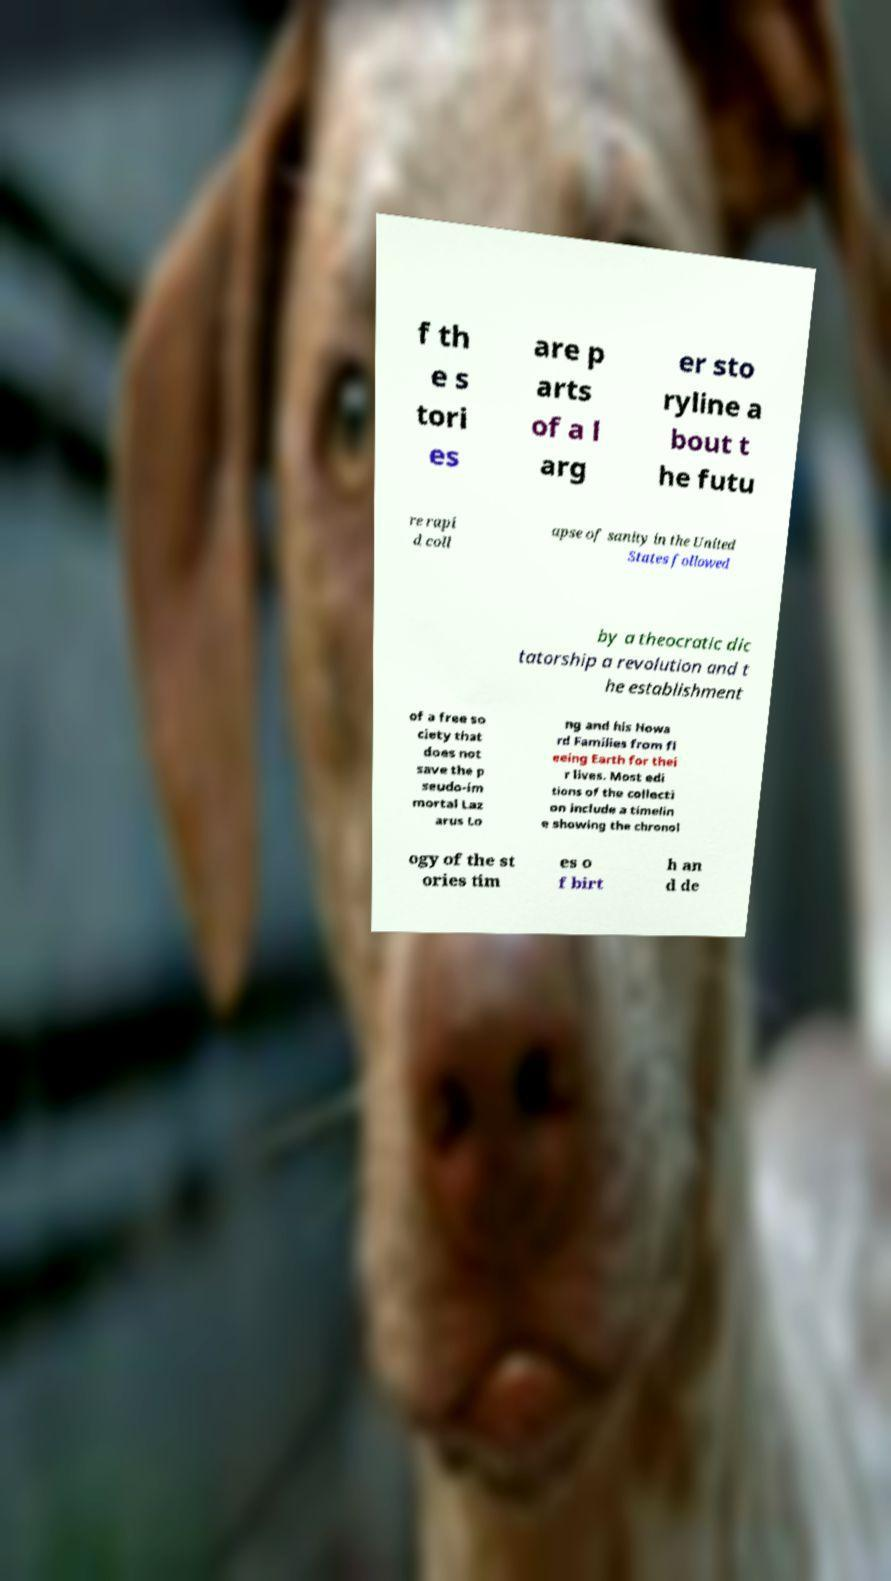What messages or text are displayed in this image? I need them in a readable, typed format. f th e s tori es are p arts of a l arg er sto ryline a bout t he futu re rapi d coll apse of sanity in the United States followed by a theocratic dic tatorship a revolution and t he establishment of a free so ciety that does not save the p seudo-im mortal Laz arus Lo ng and his Howa rd Families from fl eeing Earth for thei r lives. Most edi tions of the collecti on include a timelin e showing the chronol ogy of the st ories tim es o f birt h an d de 